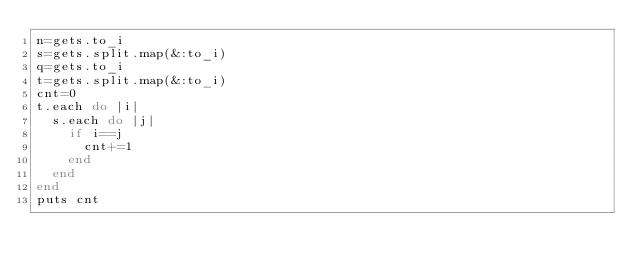Convert code to text. <code><loc_0><loc_0><loc_500><loc_500><_Ruby_>n=gets.to_i
s=gets.split.map(&:to_i)
q=gets.to_i
t=gets.split.map(&:to_i)
cnt=0
t.each do |i|
  s.each do |j|
    if i==j
      cnt+=1
    end
  end
end
puts cnt</code> 